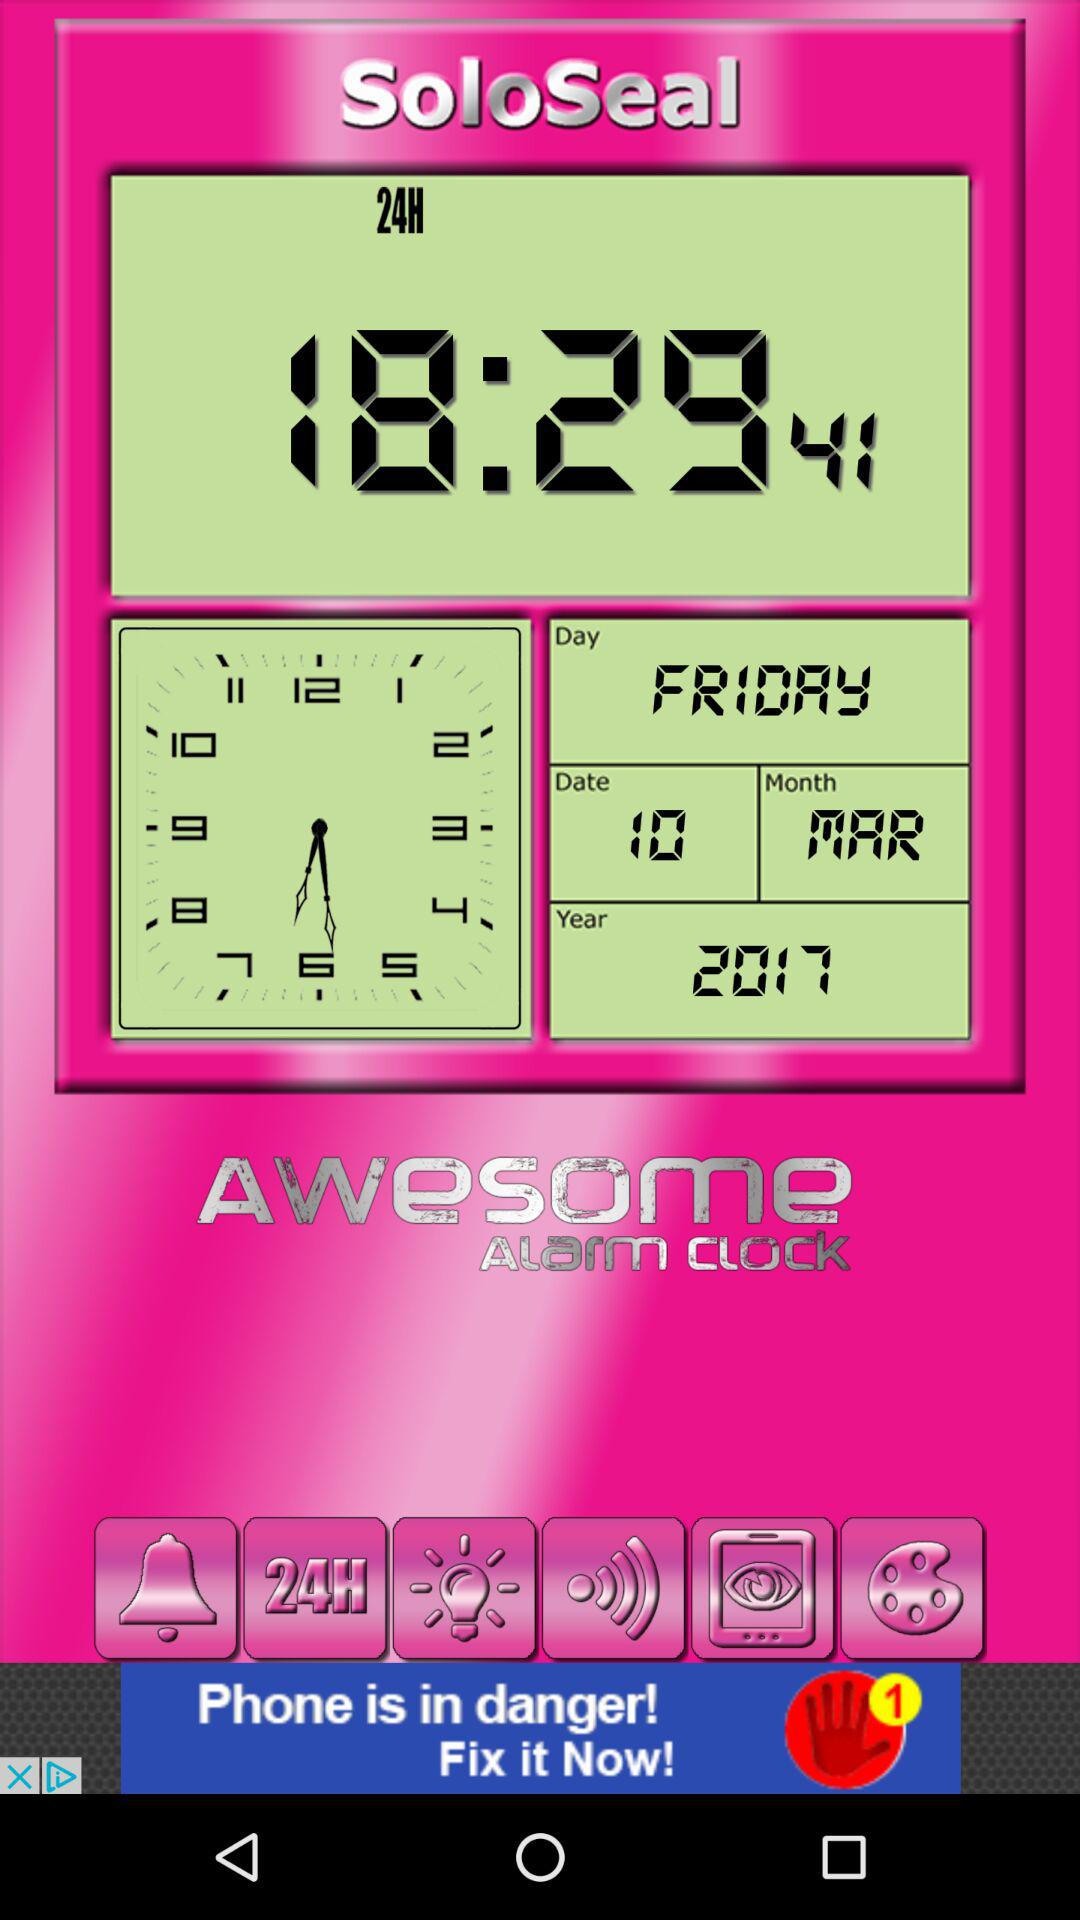What is the date today? The date today is Friday, March 10, 2017. 